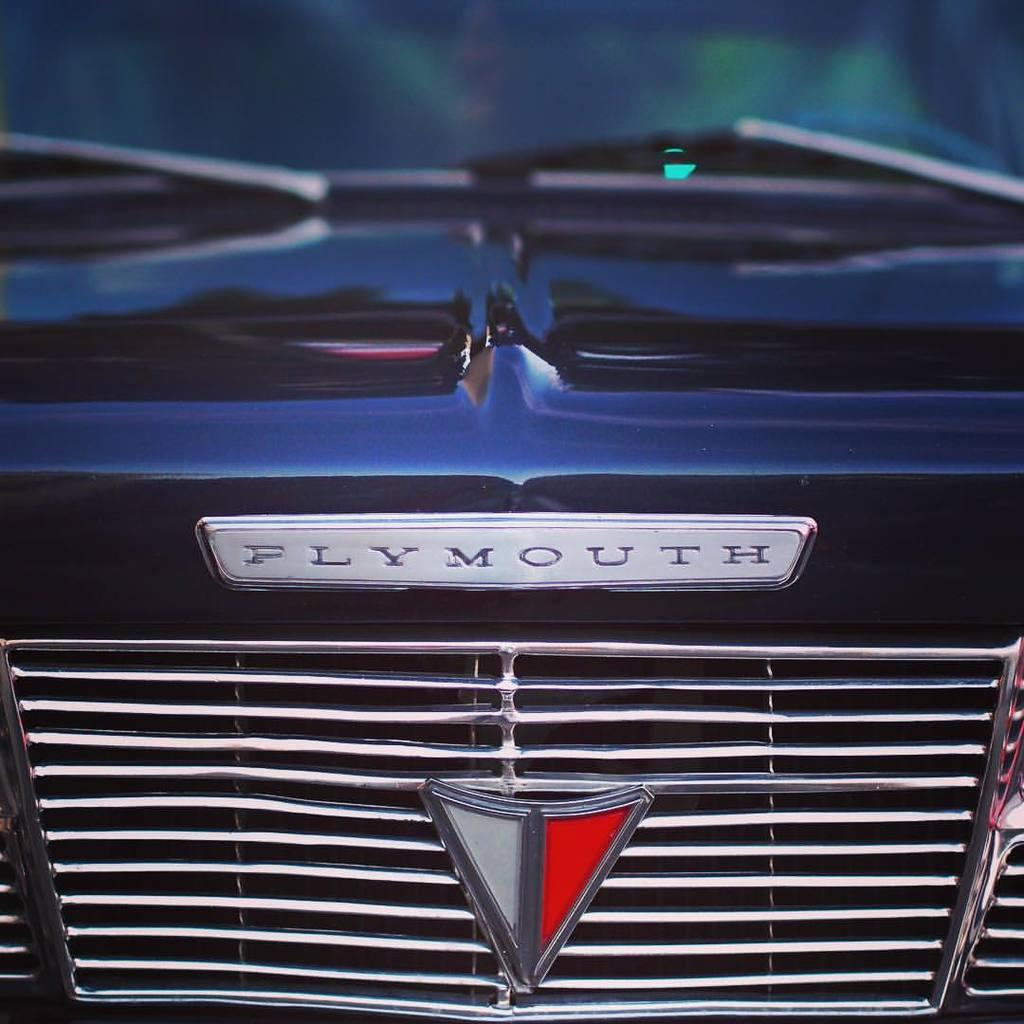What is the main subject of the image? The main subject of the image is a vehicle. How is the vehicle depicted in the image? The vehicle appears to be truncated in the image. Is there any branding or identification on the vehicle? Yes, there is a logo visible on the vehicle. What else can be seen in the image besides the vehicle? There is a board in the image. How many rabbits are sitting on the board in the image? There are no rabbits present in the image; only the vehicle and the board are visible. Can you tell me the color of the sheep in the image? There are no sheep present in the image. 